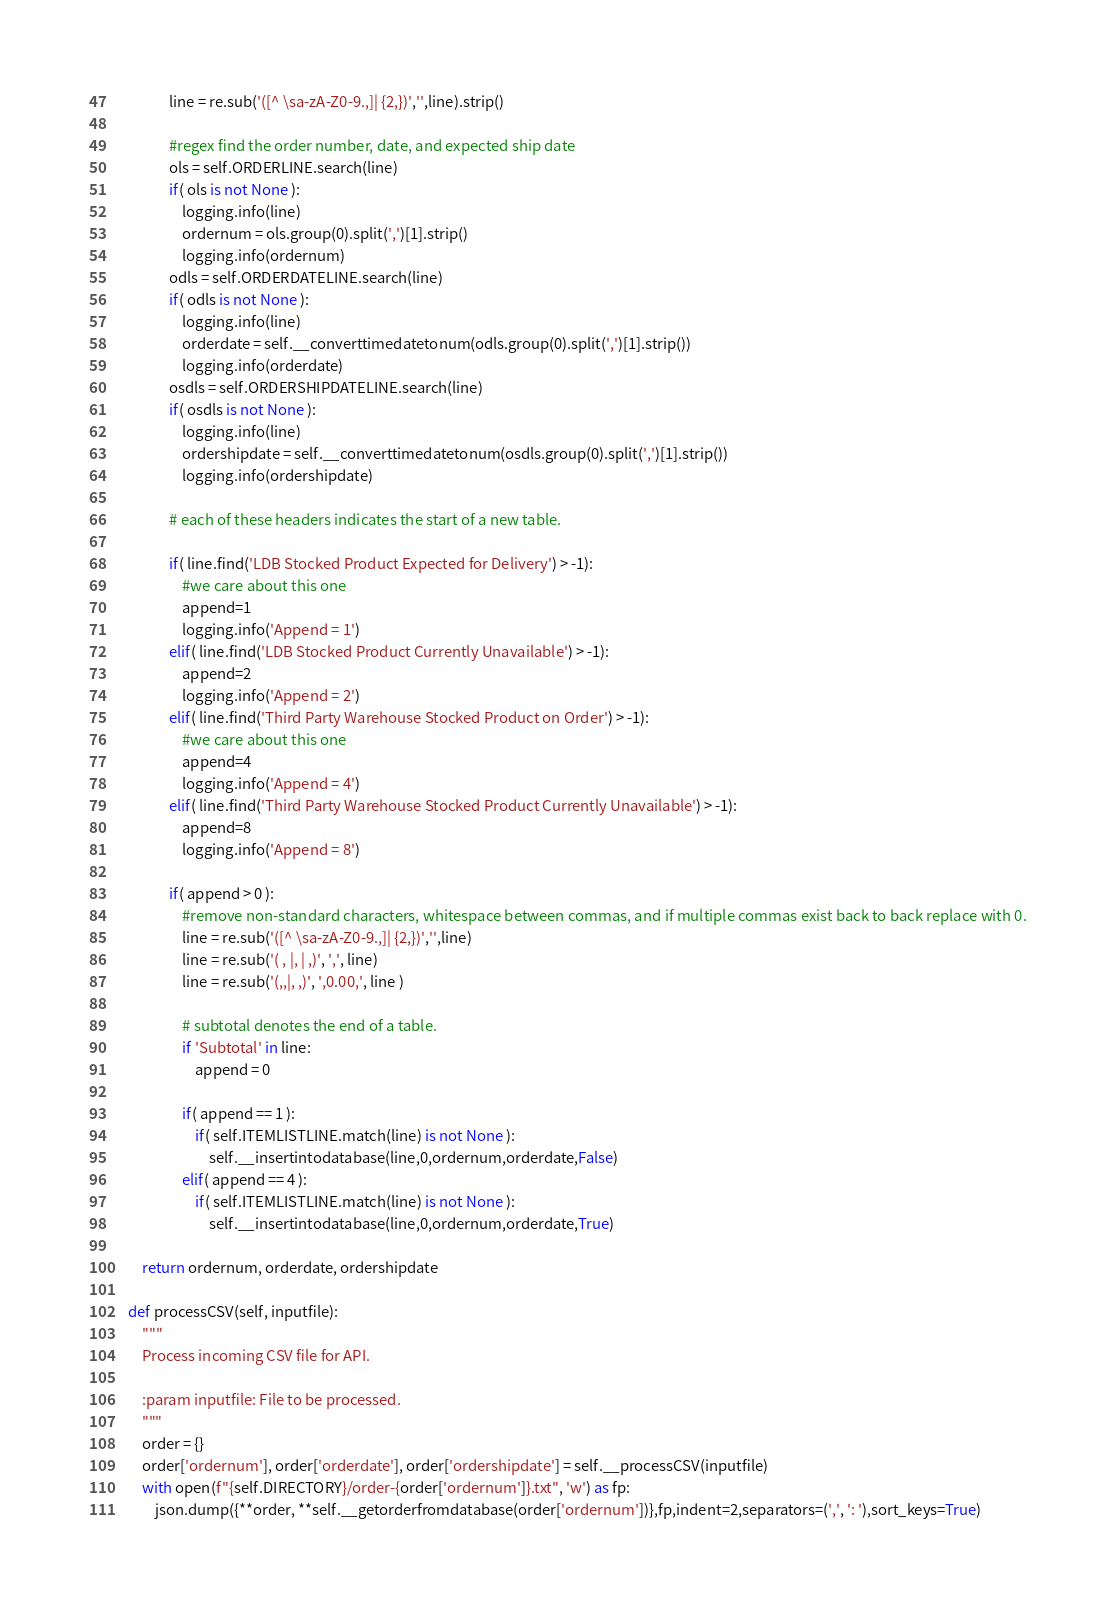<code> <loc_0><loc_0><loc_500><loc_500><_Python_>                line = re.sub('([^ \sa-zA-Z0-9.,]| {2,})','',line).strip()

                #regex find the order number, date, and expected ship date
                ols = self.ORDERLINE.search(line)
                if( ols is not None ):
                    logging.info(line)
                    ordernum = ols.group(0).split(',')[1].strip()
                    logging.info(ordernum)
                odls = self.ORDERDATELINE.search(line)
                if( odls is not None ):
                    logging.info(line)
                    orderdate = self.__converttimedatetonum(odls.group(0).split(',')[1].strip())
                    logging.info(orderdate)
                osdls = self.ORDERSHIPDATELINE.search(line)
                if( osdls is not None ):
                    logging.info(line)
                    ordershipdate = self.__converttimedatetonum(osdls.group(0).split(',')[1].strip())
                    logging.info(ordershipdate)

                # each of these headers indicates the start of a new table.

                if( line.find('LDB Stocked Product Expected for Delivery') > -1):
                    #we care about this one
                    append=1
                    logging.info('Append = 1')
                elif( line.find('LDB Stocked Product Currently Unavailable') > -1):
                    append=2
                    logging.info('Append = 2')
                elif( line.find('Third Party Warehouse Stocked Product on Order') > -1):
                    #we care about this one
                    append=4
                    logging.info('Append = 4')
                elif( line.find('Third Party Warehouse Stocked Product Currently Unavailable') > -1):
                    append=8
                    logging.info('Append = 8')

                if( append > 0 ):
                    #remove non-standard characters, whitespace between commas, and if multiple commas exist back to back replace with 0.
                    line = re.sub('([^ \sa-zA-Z0-9.,]| {2,})','',line)
                    line = re.sub('( , |, | ,)', ',', line)
                    line = re.sub('(,,|, ,)', ',0.00,', line )

                    # subtotal denotes the end of a table.
                    if 'Subtotal' in line:
                        append = 0

                    if( append == 1 ):
                        if( self.ITEMLISTLINE.match(line) is not None ):
                            self.__insertintodatabase(line,0,ordernum,orderdate,False)
                    elif( append == 4 ):
                        if( self.ITEMLISTLINE.match(line) is not None ):
                            self.__insertintodatabase(line,0,ordernum,orderdate,True)

        return ordernum, orderdate, ordershipdate

    def processCSV(self, inputfile):
        """
        Process incoming CSV file for API.

        :param inputfile: File to be processed.
        """
        order = {}
        order['ordernum'], order['orderdate'], order['ordershipdate'] = self.__processCSV(inputfile)
        with open(f"{self.DIRECTORY}/order-{order['ordernum']}.txt", 'w') as fp:
            json.dump({**order, **self.__getorderfromdatabase(order['ordernum'])},fp,indent=2,separators=(',', ': '),sort_keys=True)

</code> 